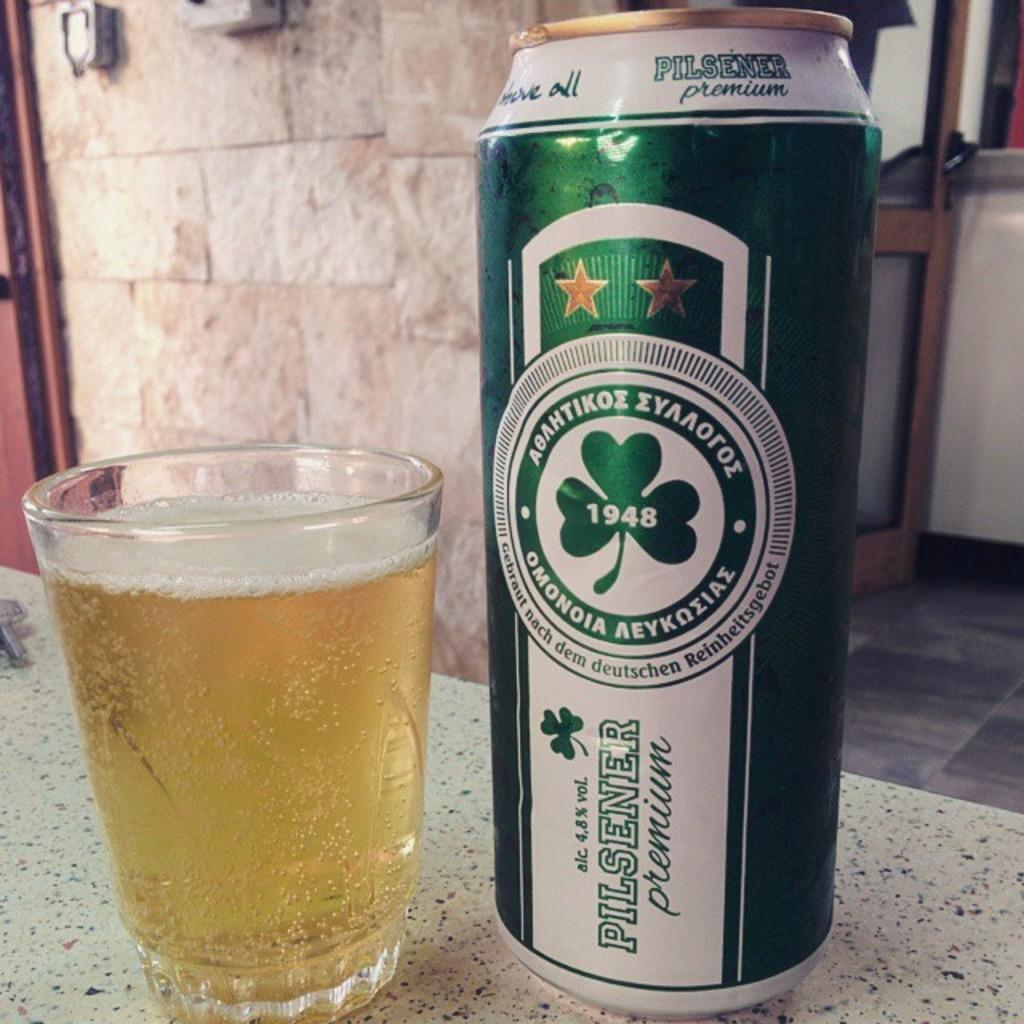What objects are on the table in the image? There is a glass and a tin on the table in the image. What can be seen in the background of the image? There is a wall in the background of the image. What architectural feature is present in the wall in the background? There is a door in the wall in the background of the image. What type of cattle can be seen grazing in the scene in the image? There is no scene or cattle present in the image; it features a table with a glass and a tin, and a wall with a door in the background. 